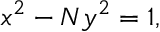Convert formula to latex. <formula><loc_0><loc_0><loc_500><loc_500>\ x ^ { 2 } - N y ^ { 2 } = 1 ,</formula> 